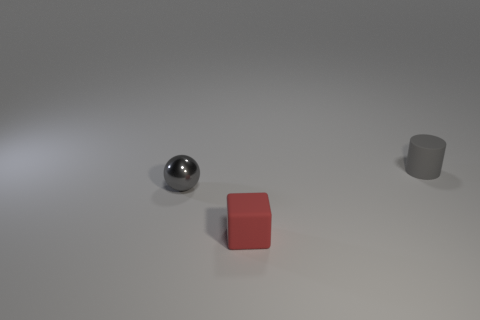How many other things are there of the same color as the tiny shiny sphere?
Provide a short and direct response. 1. What is the thing in front of the sphere made of?
Keep it short and to the point. Rubber. Is there a red metal cylinder of the same size as the red thing?
Keep it short and to the point. No. Do the small object that is behind the gray shiny ball and the tiny metal ball have the same color?
Keep it short and to the point. Yes. What number of gray objects are either small metallic objects or matte things?
Make the answer very short. 2. How many tiny rubber blocks have the same color as the shiny ball?
Keep it short and to the point. 0. Is the material of the gray ball the same as the cylinder?
Your response must be concise. No. How many gray balls are behind the tiny rubber object left of the gray cylinder?
Keep it short and to the point. 1. Do the cylinder and the gray metal thing have the same size?
Your answer should be very brief. Yes. What number of tiny gray spheres have the same material as the small red object?
Offer a terse response. 0. 